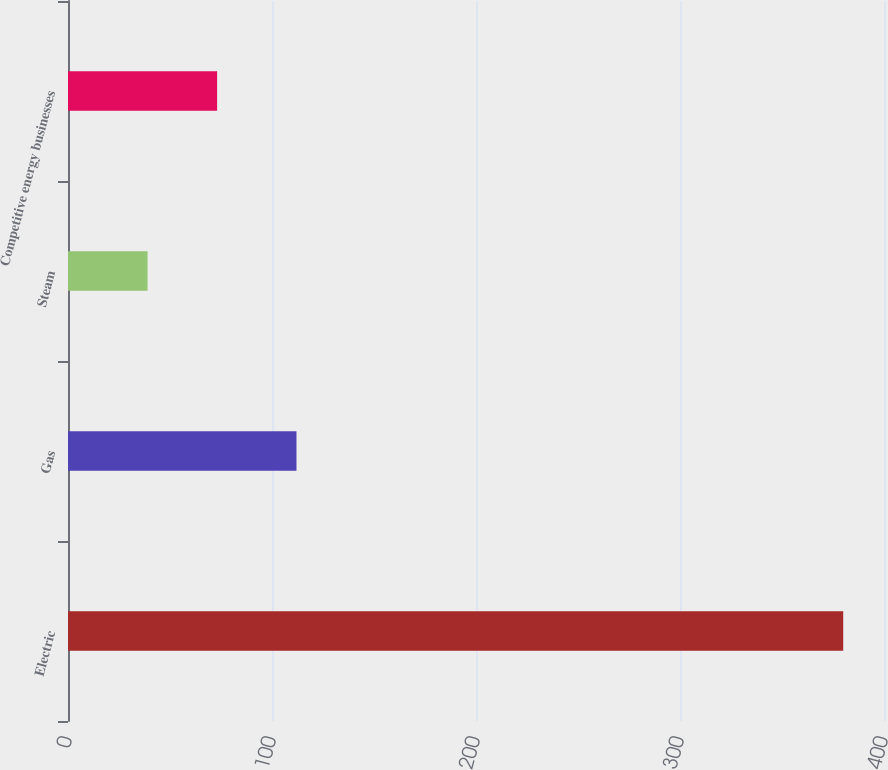Convert chart. <chart><loc_0><loc_0><loc_500><loc_500><bar_chart><fcel>Electric<fcel>Gas<fcel>Steam<fcel>Competitive energy businesses<nl><fcel>380<fcel>112<fcel>39<fcel>73.1<nl></chart> 